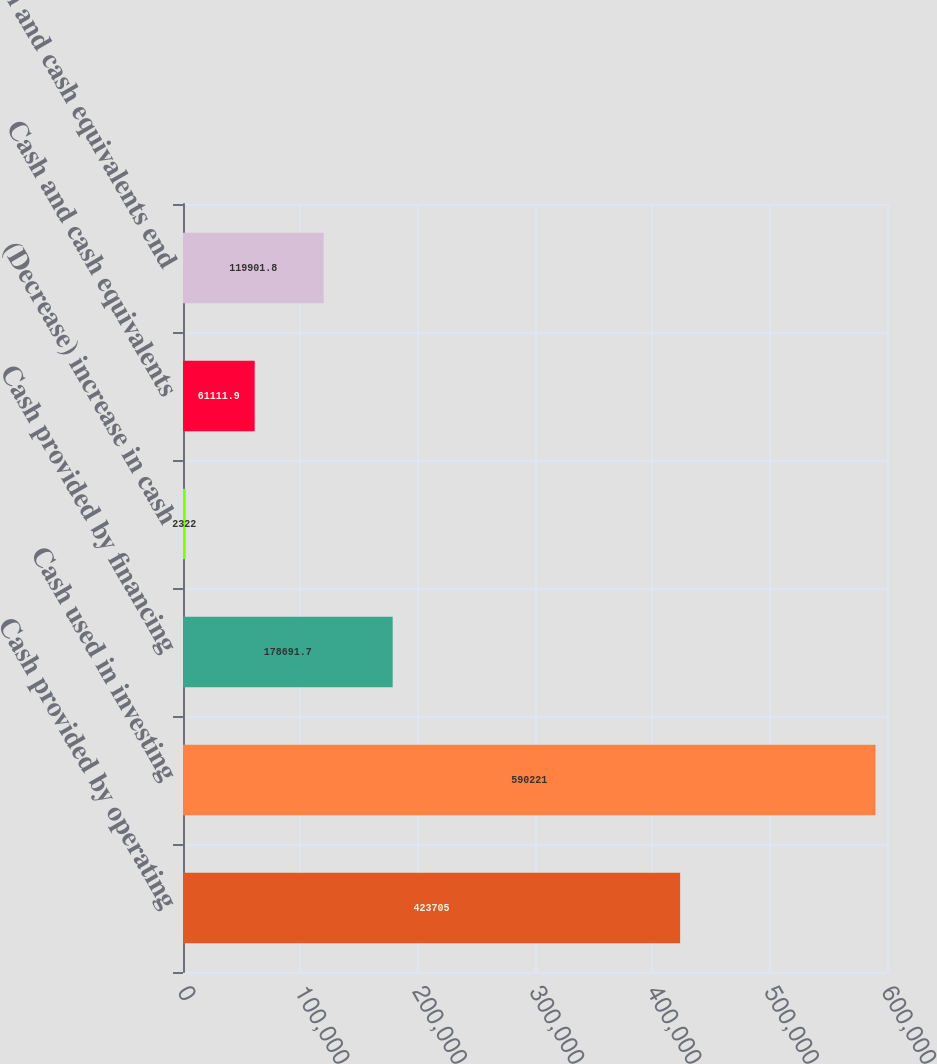Convert chart. <chart><loc_0><loc_0><loc_500><loc_500><bar_chart><fcel>Cash provided by operating<fcel>Cash used in investing<fcel>Cash provided by financing<fcel>(Decrease) increase in cash<fcel>Cash and cash equivalents<fcel>Cash and cash equivalents end<nl><fcel>423705<fcel>590221<fcel>178692<fcel>2322<fcel>61111.9<fcel>119902<nl></chart> 